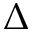Convert formula to latex. <formula><loc_0><loc_0><loc_500><loc_500>\Delta</formula> 